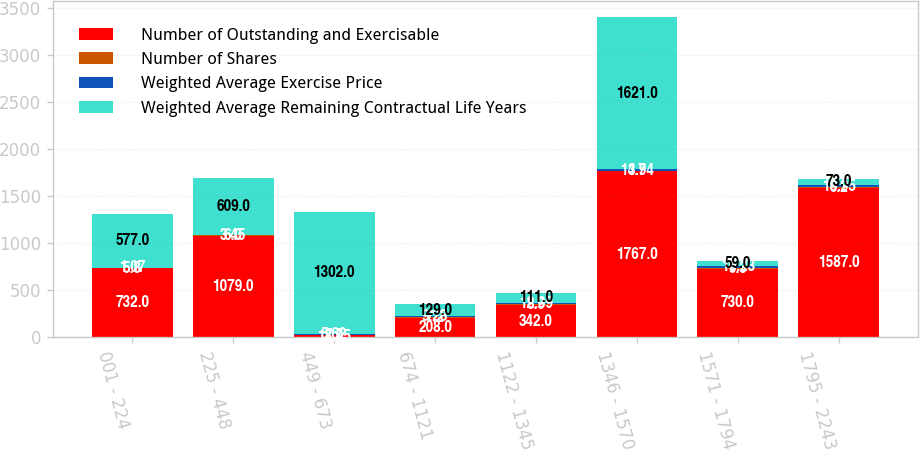Convert chart to OTSL. <chart><loc_0><loc_0><loc_500><loc_500><stacked_bar_chart><ecel><fcel>001 - 224<fcel>225 - 448<fcel>449 - 673<fcel>674 - 1121<fcel>1122 - 1345<fcel>1346 - 1570<fcel>1571 - 1794<fcel>1795 - 2243<nl><fcel>Number of Outstanding and Exercisable<fcel>732<fcel>1079<fcel>18.95<fcel>208<fcel>342<fcel>1767<fcel>730<fcel>1587<nl><fcel>Number of Shares<fcel>5.8<fcel>6<fcel>7.7<fcel>7.2<fcel>8.9<fcel>3.7<fcel>9.3<fcel>9.2<nl><fcel>Weighted Average Exercise Price<fcel>1.07<fcel>3.45<fcel>5.62<fcel>9.28<fcel>12.39<fcel>14.94<fcel>16.23<fcel>18.95<nl><fcel>Weighted Average Remaining Contractual Life Years<fcel>577<fcel>609<fcel>1302<fcel>129<fcel>111<fcel>1621<fcel>59<fcel>73<nl></chart> 